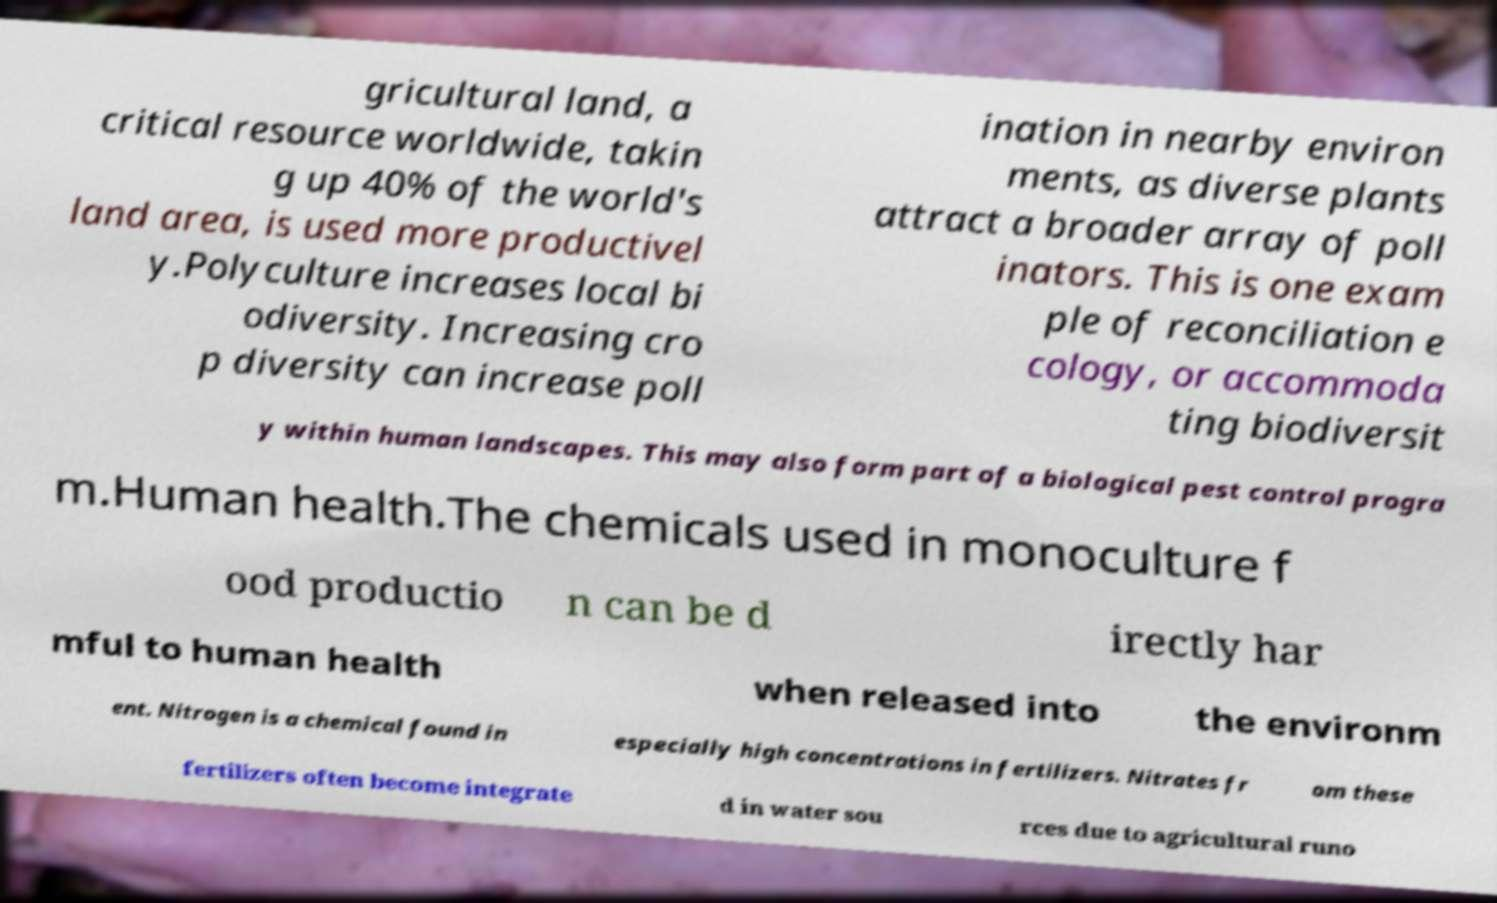Please identify and transcribe the text found in this image. gricultural land, a critical resource worldwide, takin g up 40% of the world's land area, is used more productivel y.Polyculture increases local bi odiversity. Increasing cro p diversity can increase poll ination in nearby environ ments, as diverse plants attract a broader array of poll inators. This is one exam ple of reconciliation e cology, or accommoda ting biodiversit y within human landscapes. This may also form part of a biological pest control progra m.Human health.The chemicals used in monoculture f ood productio n can be d irectly har mful to human health when released into the environm ent. Nitrogen is a chemical found in especially high concentrations in fertilizers. Nitrates fr om these fertilizers often become integrate d in water sou rces due to agricultural runo 